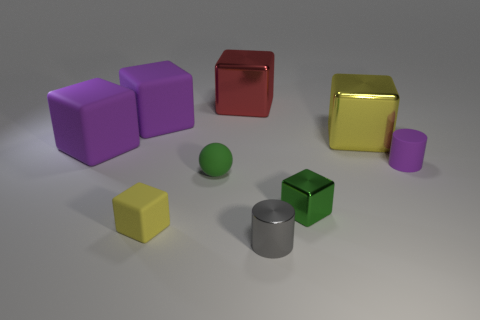Subtract all small shiny blocks. How many blocks are left? 5 Subtract all purple blocks. How many blocks are left? 4 Subtract all blue blocks. Subtract all brown cylinders. How many blocks are left? 6 Subtract all spheres. How many objects are left? 8 Add 2 large blue shiny cubes. How many large blue shiny cubes exist? 2 Subtract 0 brown blocks. How many objects are left? 9 Subtract all tiny gray cylinders. Subtract all small matte things. How many objects are left? 5 Add 6 small matte objects. How many small matte objects are left? 9 